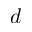<formula> <loc_0><loc_0><loc_500><loc_500>d</formula> 